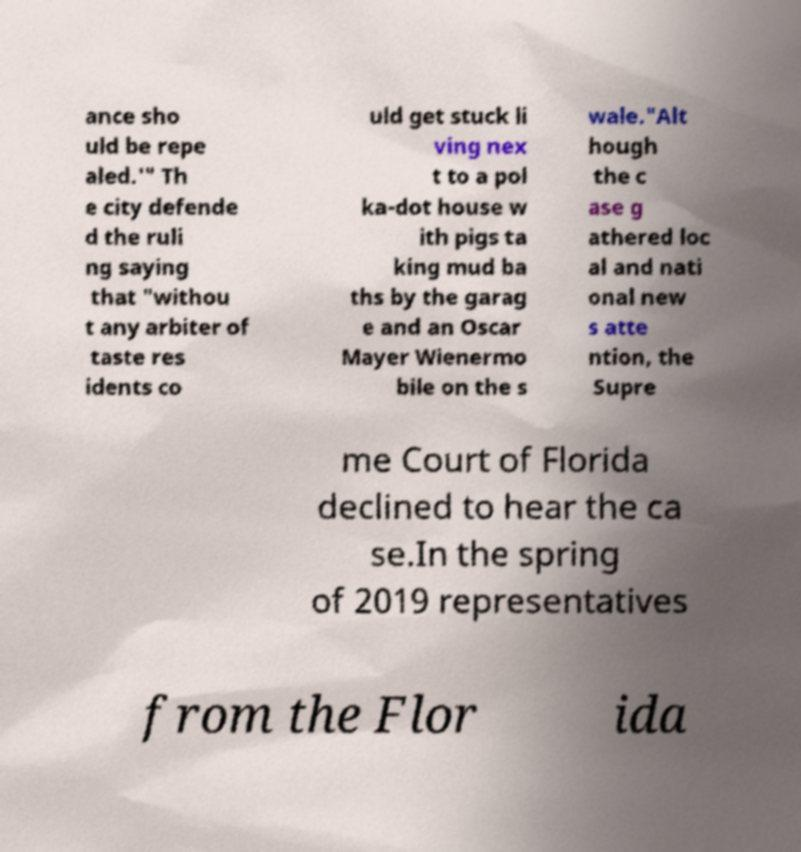Could you assist in decoding the text presented in this image and type it out clearly? ance sho uld be repe aled.'" Th e city defende d the ruli ng saying that "withou t any arbiter of taste res idents co uld get stuck li ving nex t to a pol ka-dot house w ith pigs ta king mud ba ths by the garag e and an Oscar Mayer Wienermo bile on the s wale."Alt hough the c ase g athered loc al and nati onal new s atte ntion, the Supre me Court of Florida declined to hear the ca se.In the spring of 2019 representatives from the Flor ida 